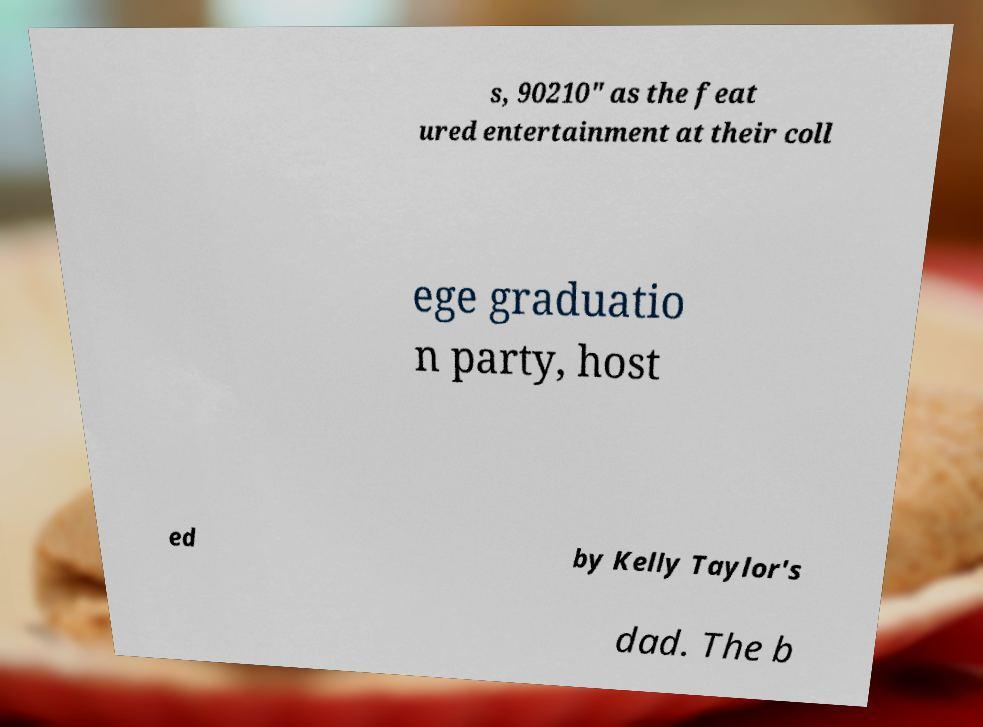Can you accurately transcribe the text from the provided image for me? s, 90210" as the feat ured entertainment at their coll ege graduatio n party, host ed by Kelly Taylor's dad. The b 